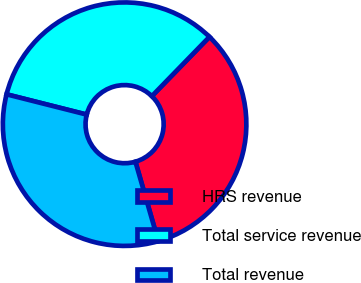Convert chart to OTSL. <chart><loc_0><loc_0><loc_500><loc_500><pie_chart><fcel>HRS revenue<fcel>Total service revenue<fcel>Total revenue<nl><fcel>33.26%<fcel>33.33%<fcel>33.4%<nl></chart> 